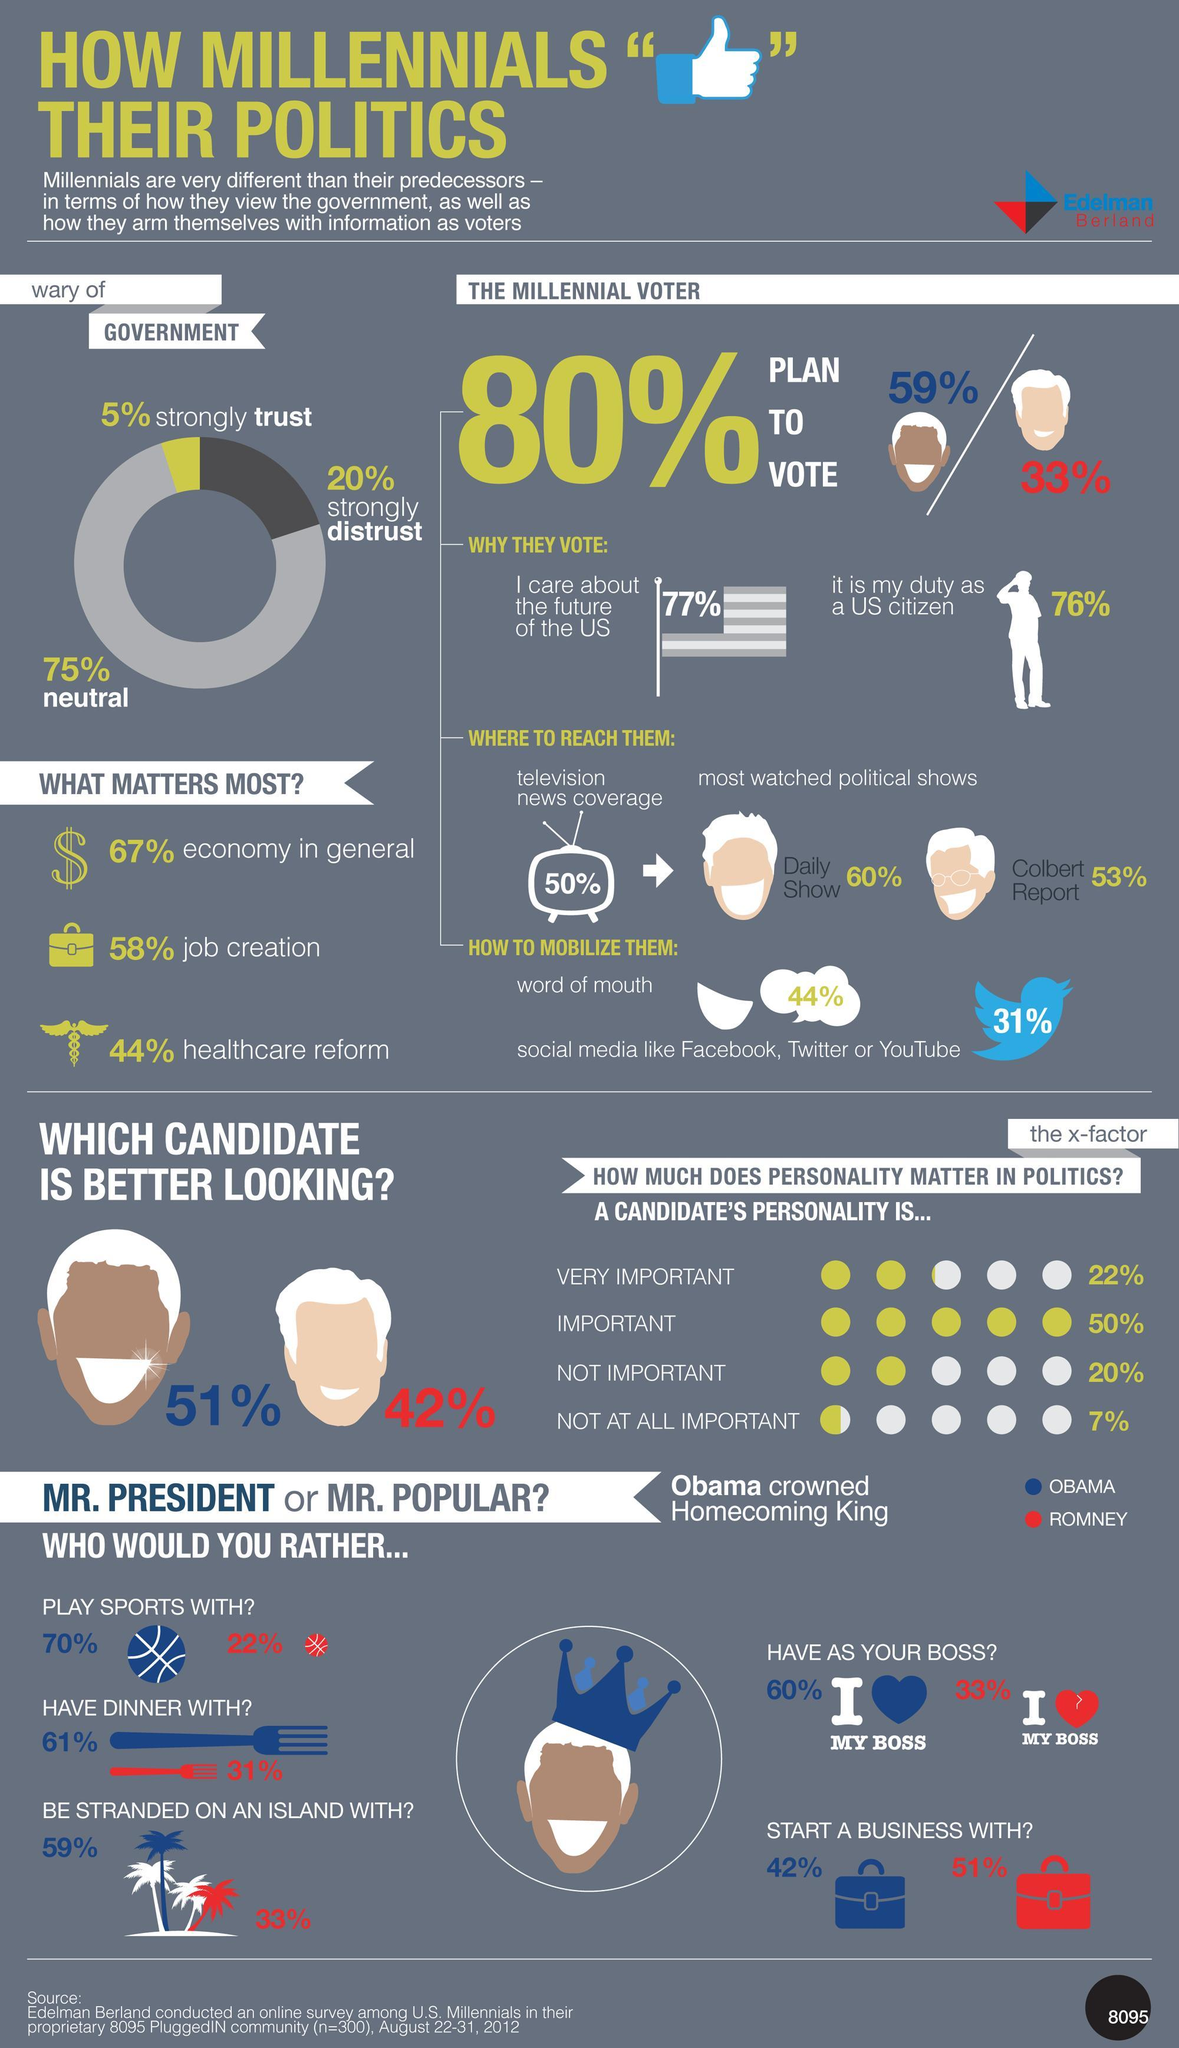What percentage of Millennial voters planned to vote for Romney?
Answer the question with a short phrase. 33% What percentage of Millenial votes can be mobilized using Twitter? 31% With whom did the majority want to start business with Romney How many felt that Obama was better looking 51% What percentage of Millennial voters planned to vote for Obama? 59% What percentage of Millenials wanted to have Obama as their boss? 60% What percentage of Millenials wanted to have dinner with Romney? 31% What percentage of millennial voters were wary of the government? 20% 